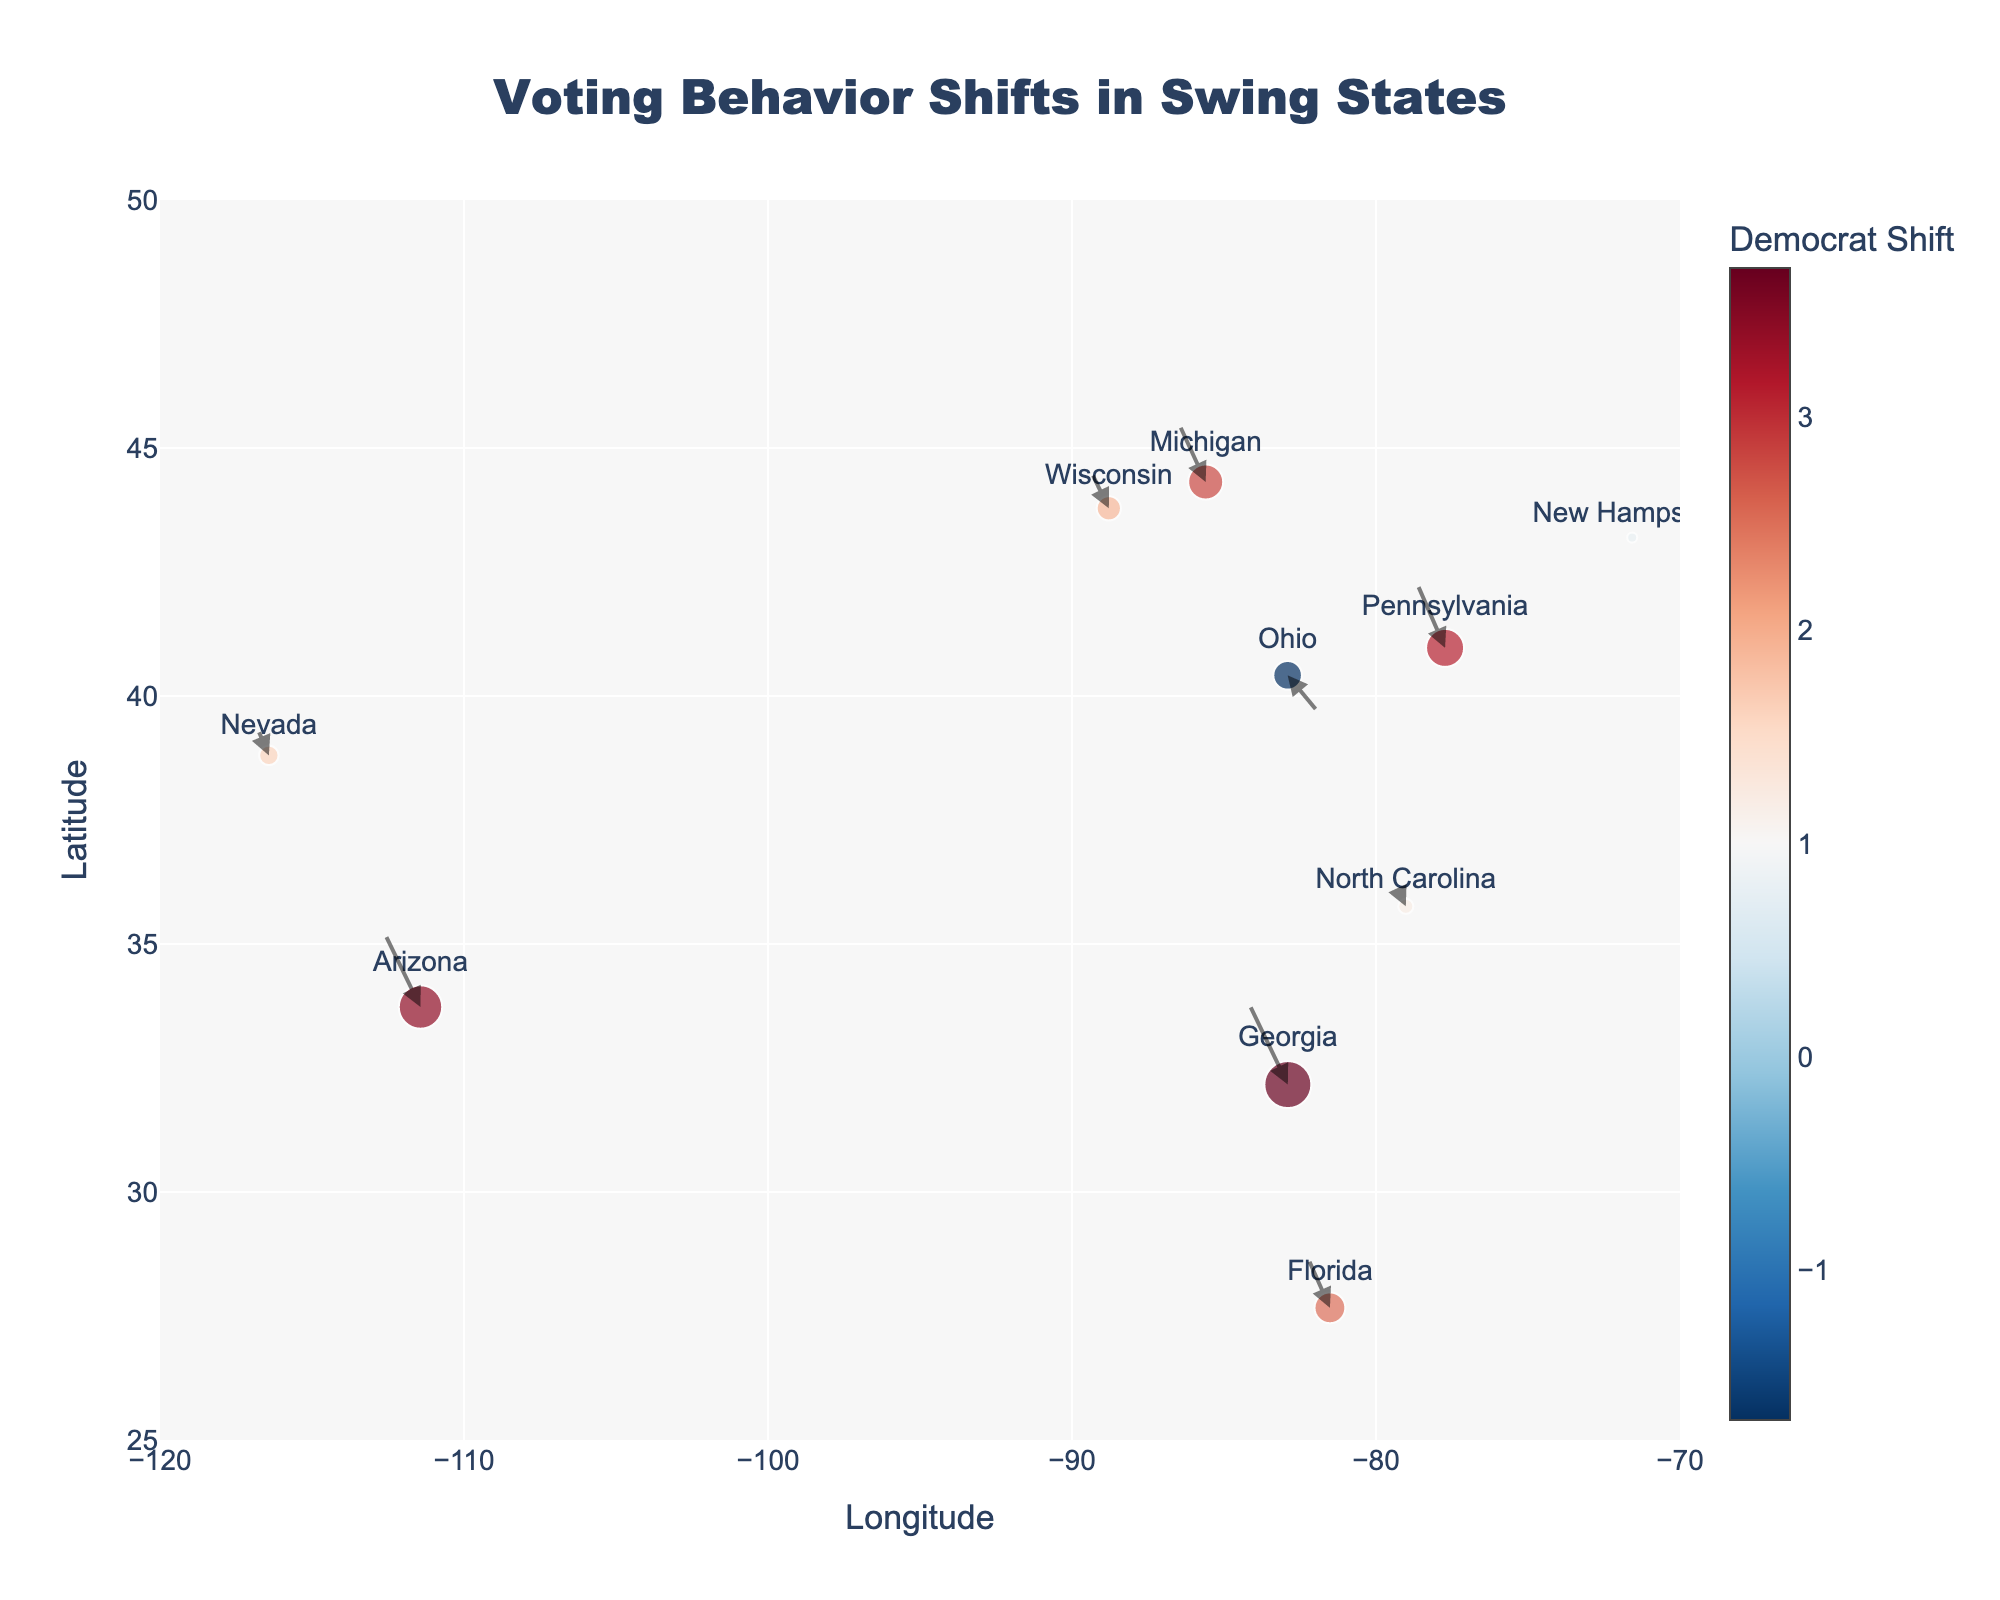What is the title of the plot? The title is displayed at the top of the figure in large, bold text.
Answer: Voting Behavior Shifts in Swing States Which state experienced the highest Democrat shift? By looking at the color intensity and size of the markers, Georgia shows the highest Democrat shift in the hover text associated with this state.
Answer: Georgia How is the color of the markers related to the data represented? The color of the markers represents the magnitude of the Democrat shift, with a color scale provided on the right side of the figure. Darker colors indicate a higher Democrat shift.
Answer: Democrat shift magnitude What is the range of the y-axis in the plot? By observing the labels on the y-axis, it is evident that it ranges from 25 to 50.
Answer: 25 to 50 Which state experienced a negative Democrat shift and a positive Republican shift? By checking the hover text for each marker, Ohio shows a negative Democrat shift (-1.7) and a positive Republican shift (2.3).
Answer: Ohio How many states show a positive Democrat shift? By visually examining the color and hover text of each state marker, all states except Ohio exhibit a positive Democrat shift.
Answer: 9 What is the common factor between states that experienced an increase in Democrat votes? States with a positive Democrat shift usually show markers in shades of red on the scale and larger marker sizes, except for Ohio.
Answer: Positive Democrat shift Among the states with a Democrat shift greater than 3.0, which state has the smallest Republican shift? Checking the hover text for states with Democrat shifts greater than 3.0, Pennsylvania has a Republican shift of -2.2, compared to Arizona (-2.7) and Georgia (-2.9), which are smaller.
Answer: Pennsylvania Which state shows the smallest net change in voting behavior (considering both Democrat and Republican shifts as vectors)? Net change magnitude can be estimated by the size of markers; New Hampshire has the smallest marker due to a smaller combined shift (Democrat shift: 0.8, Republican shift: -0.6).
Answer: New Hampshire 